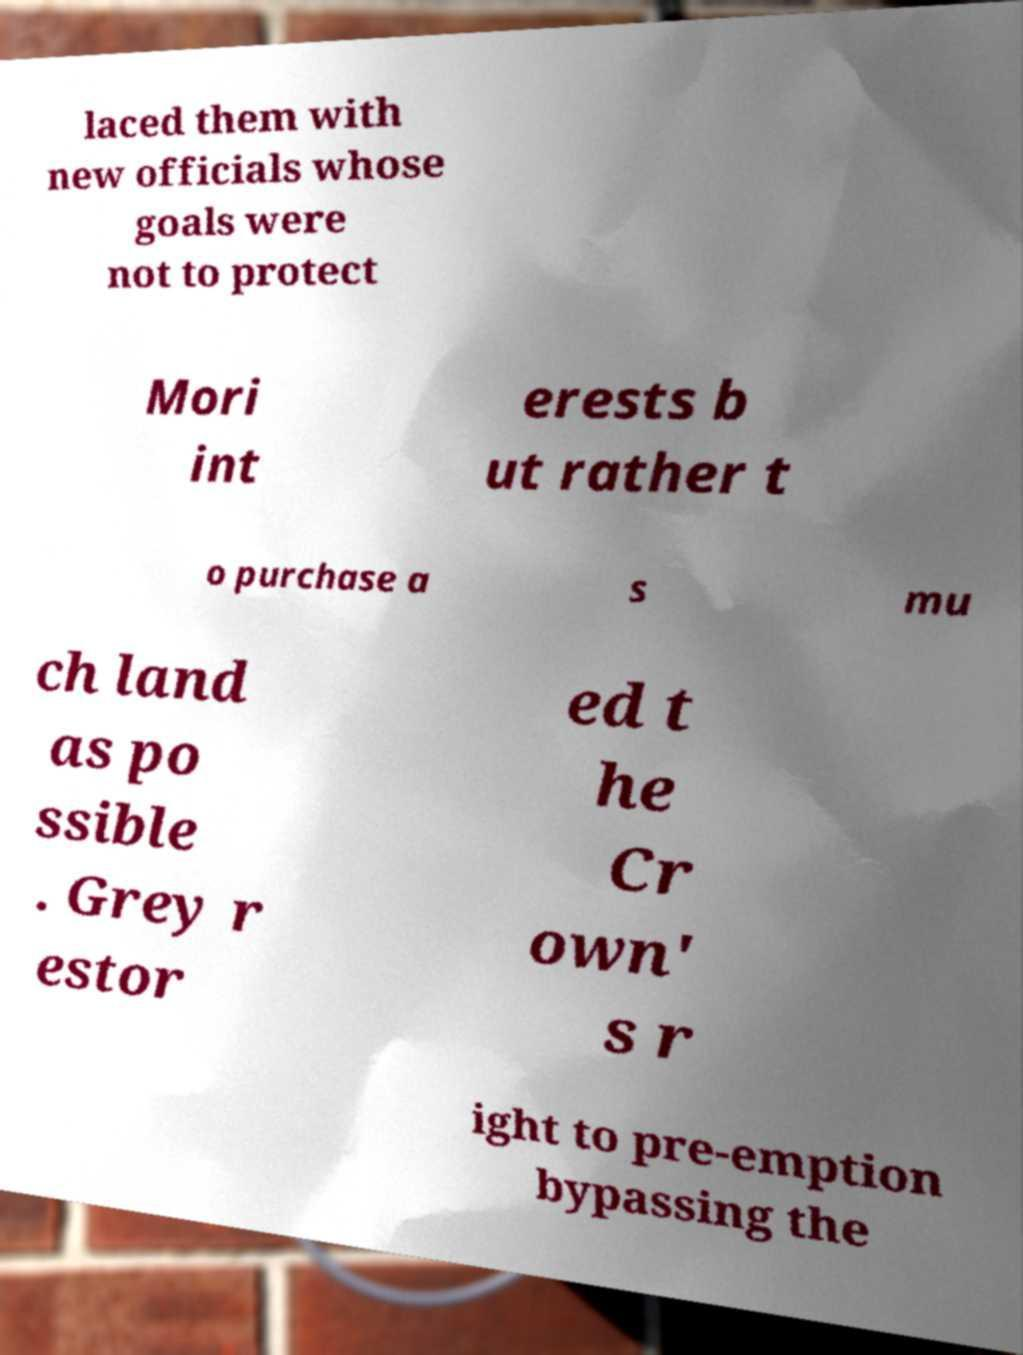There's text embedded in this image that I need extracted. Can you transcribe it verbatim? laced them with new officials whose goals were not to protect Mori int erests b ut rather t o purchase a s mu ch land as po ssible . Grey r estor ed t he Cr own' s r ight to pre-emption bypassing the 